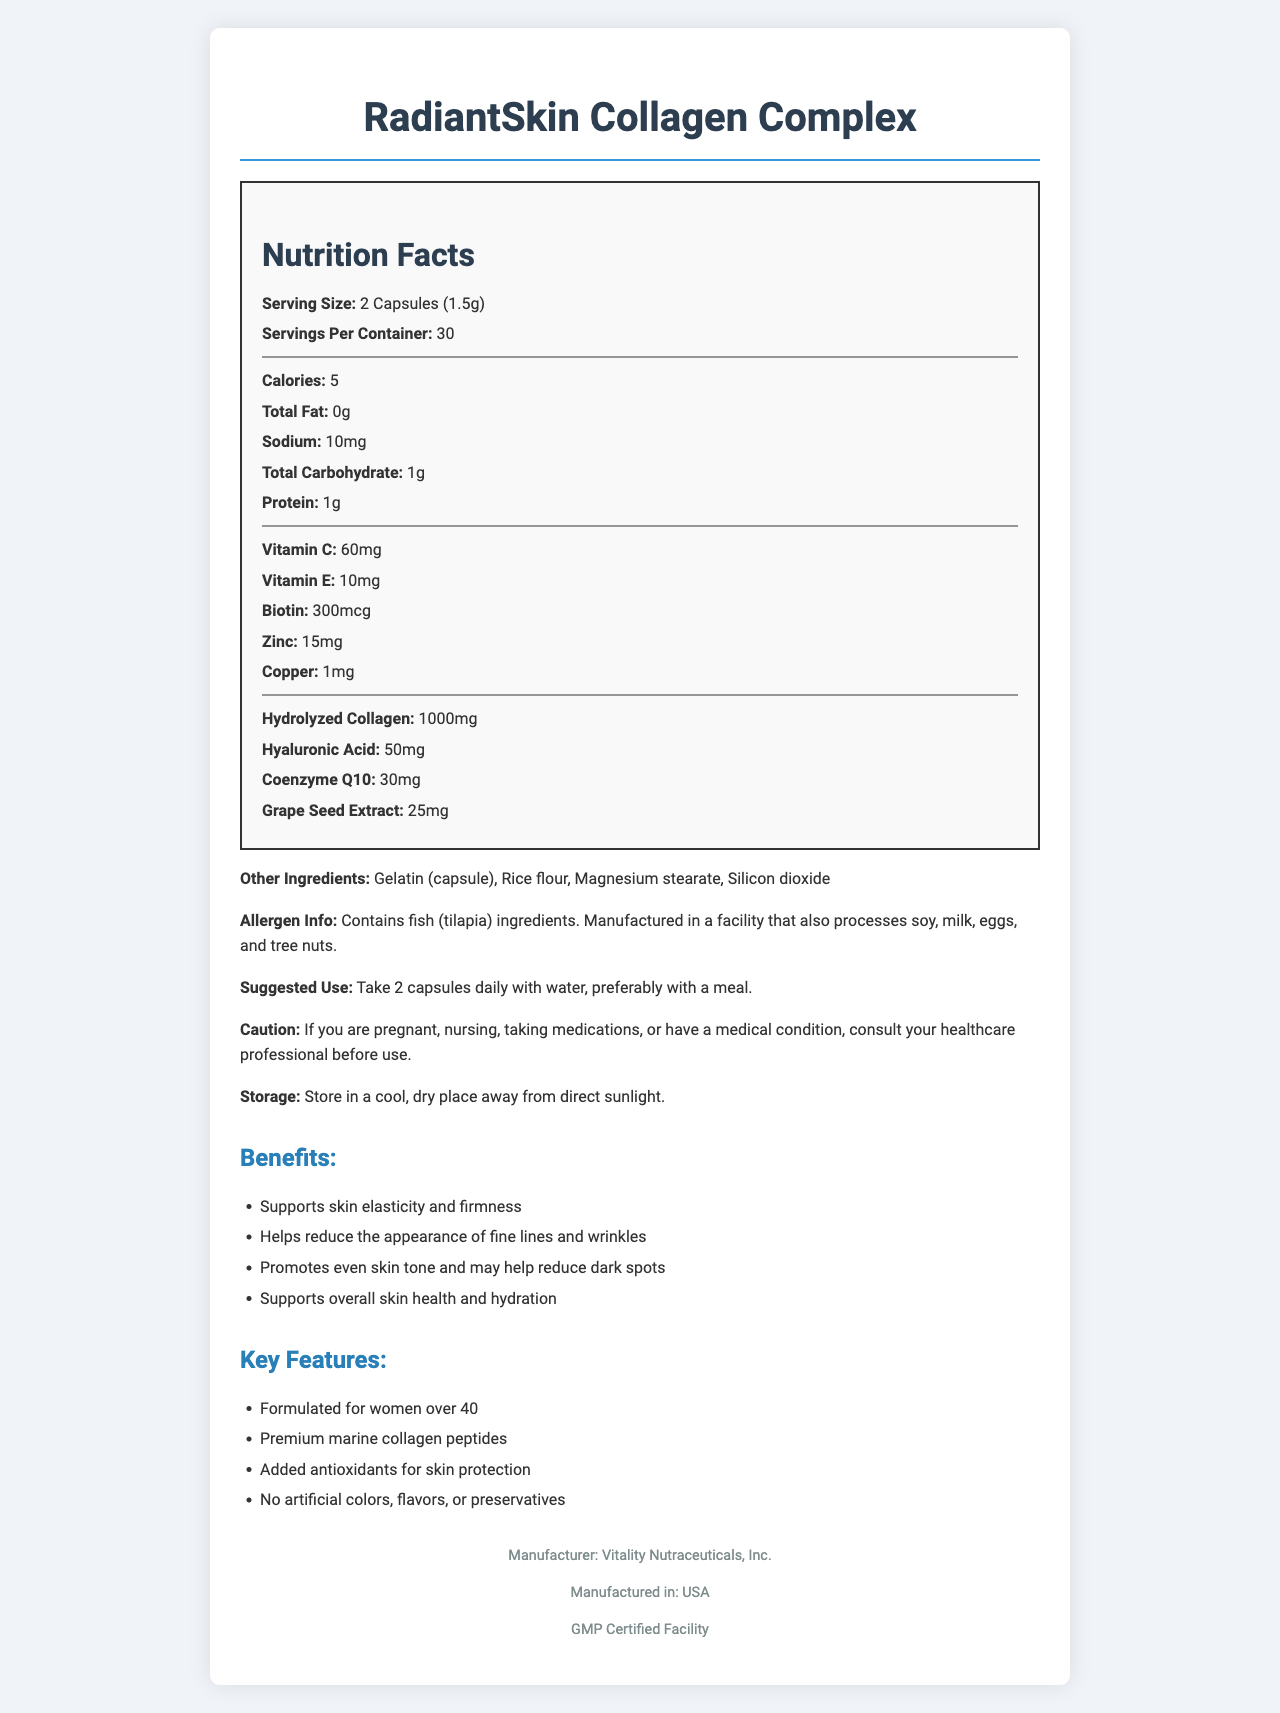What is the serving size of RadiantSkin Collagen Complex? The document states that the serving size is 2 capsules, which amounts to 1.5 grams.
Answer: 2 Capsules (1.5g) How many capsules are in the container? The document indicates there are 30 servings per container, with each serving consisting of 2 capsules, totaling 60 capsules per container.
Answer: 60 capsules How much Vitamin C is present per serving? The nutrition facts list Vitamin C with a content of 60mg per serving.
Answer: 60mg List one benefit of the RadiantSkin Collagen Complex. The document lists several benefits, one of which is supporting skin elasticity and firmness.
Answer: Supports skin elasticity and firmness What is the main protein ingredient in RadiantSkin Collagen Complex? The document mentions hydrolyzed collagen as the main protein ingredient.
Answer: Hydrolyzed Collagen Which ingredient provides antioxidants for skin protection? 
A. Zinc 
B. Grapeseed Extract 
C. Coenzyme Q10 
D. Copper The document lists grapeseed extract as an ingredient that provides antioxidants for skin protection.
Answer: B What is the suggested use for RadiantSkin Collagen Complex?
I. Take 1 capsule daily 
II. Take 2 capsules daily 
III. Take 3 capsules daily with water 
IV. Take 2 capsules daily with water, preferably with a meal The document specifies that the suggested use is to take 2 capsules daily with water, preferably with a meal.
Answer: IV Does the product contain any artificial colors, flavors, or preservatives? The document highlights that the product has no artificial colors, flavors, or preservatives.
Answer: No Summarize the main benefits and features of RadiantSkin Collagen Complex. The document outlines the product's benefits, such as improving skin elasticity, reducing wrinkles and dark spots, and providing skin hydration. Key features include targeted formulation for women over 40, high-quality collagen peptides, antioxidants, and no artificial additives.
Answer: RadiantSkin Collagen Complex is designed to support skin health and elasticity for women over 40. It helps reduce the appearance of fine lines, wrinkles, and dark spots, promoting an even skin tone and overall skin hydration. Key features include premium marine collagen peptides, added antioxidants for skin protection, and the absence of artificial additives. What is the exact source of the marine collagen peptides used in the product? The document mentions premium marine collagen peptides but does not specify the exact source or species.
Answer: Not enough information 